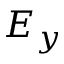Convert formula to latex. <formula><loc_0><loc_0><loc_500><loc_500>E _ { y }</formula> 